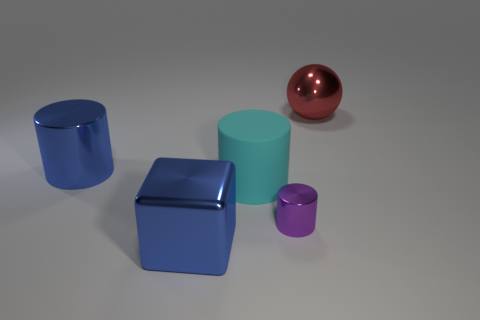There is another cylinder that is made of the same material as the blue cylinder; what is its color?
Give a very brief answer. Purple. Are there fewer tiny shiny things that are behind the metallic sphere than objects?
Offer a very short reply. Yes. What is the shape of the red object that is the same material as the purple cylinder?
Keep it short and to the point. Sphere. What number of shiny things are blue cylinders or small brown cubes?
Give a very brief answer. 1. Is the number of cyan things that are on the right side of the tiny thing the same as the number of blue cubes?
Keep it short and to the point. No. There is a metallic cylinder in front of the big blue cylinder; does it have the same color as the rubber cylinder?
Ensure brevity in your answer.  No. There is a thing that is in front of the cyan thing and behind the big blue cube; what is its material?
Your response must be concise. Metal. There is a red ball that is behind the small metallic object; is there a big red sphere that is in front of it?
Offer a terse response. No. Is the material of the large red object the same as the block?
Your response must be concise. Yes. The big metallic object that is both in front of the shiny ball and behind the small metallic thing has what shape?
Offer a very short reply. Cylinder. 